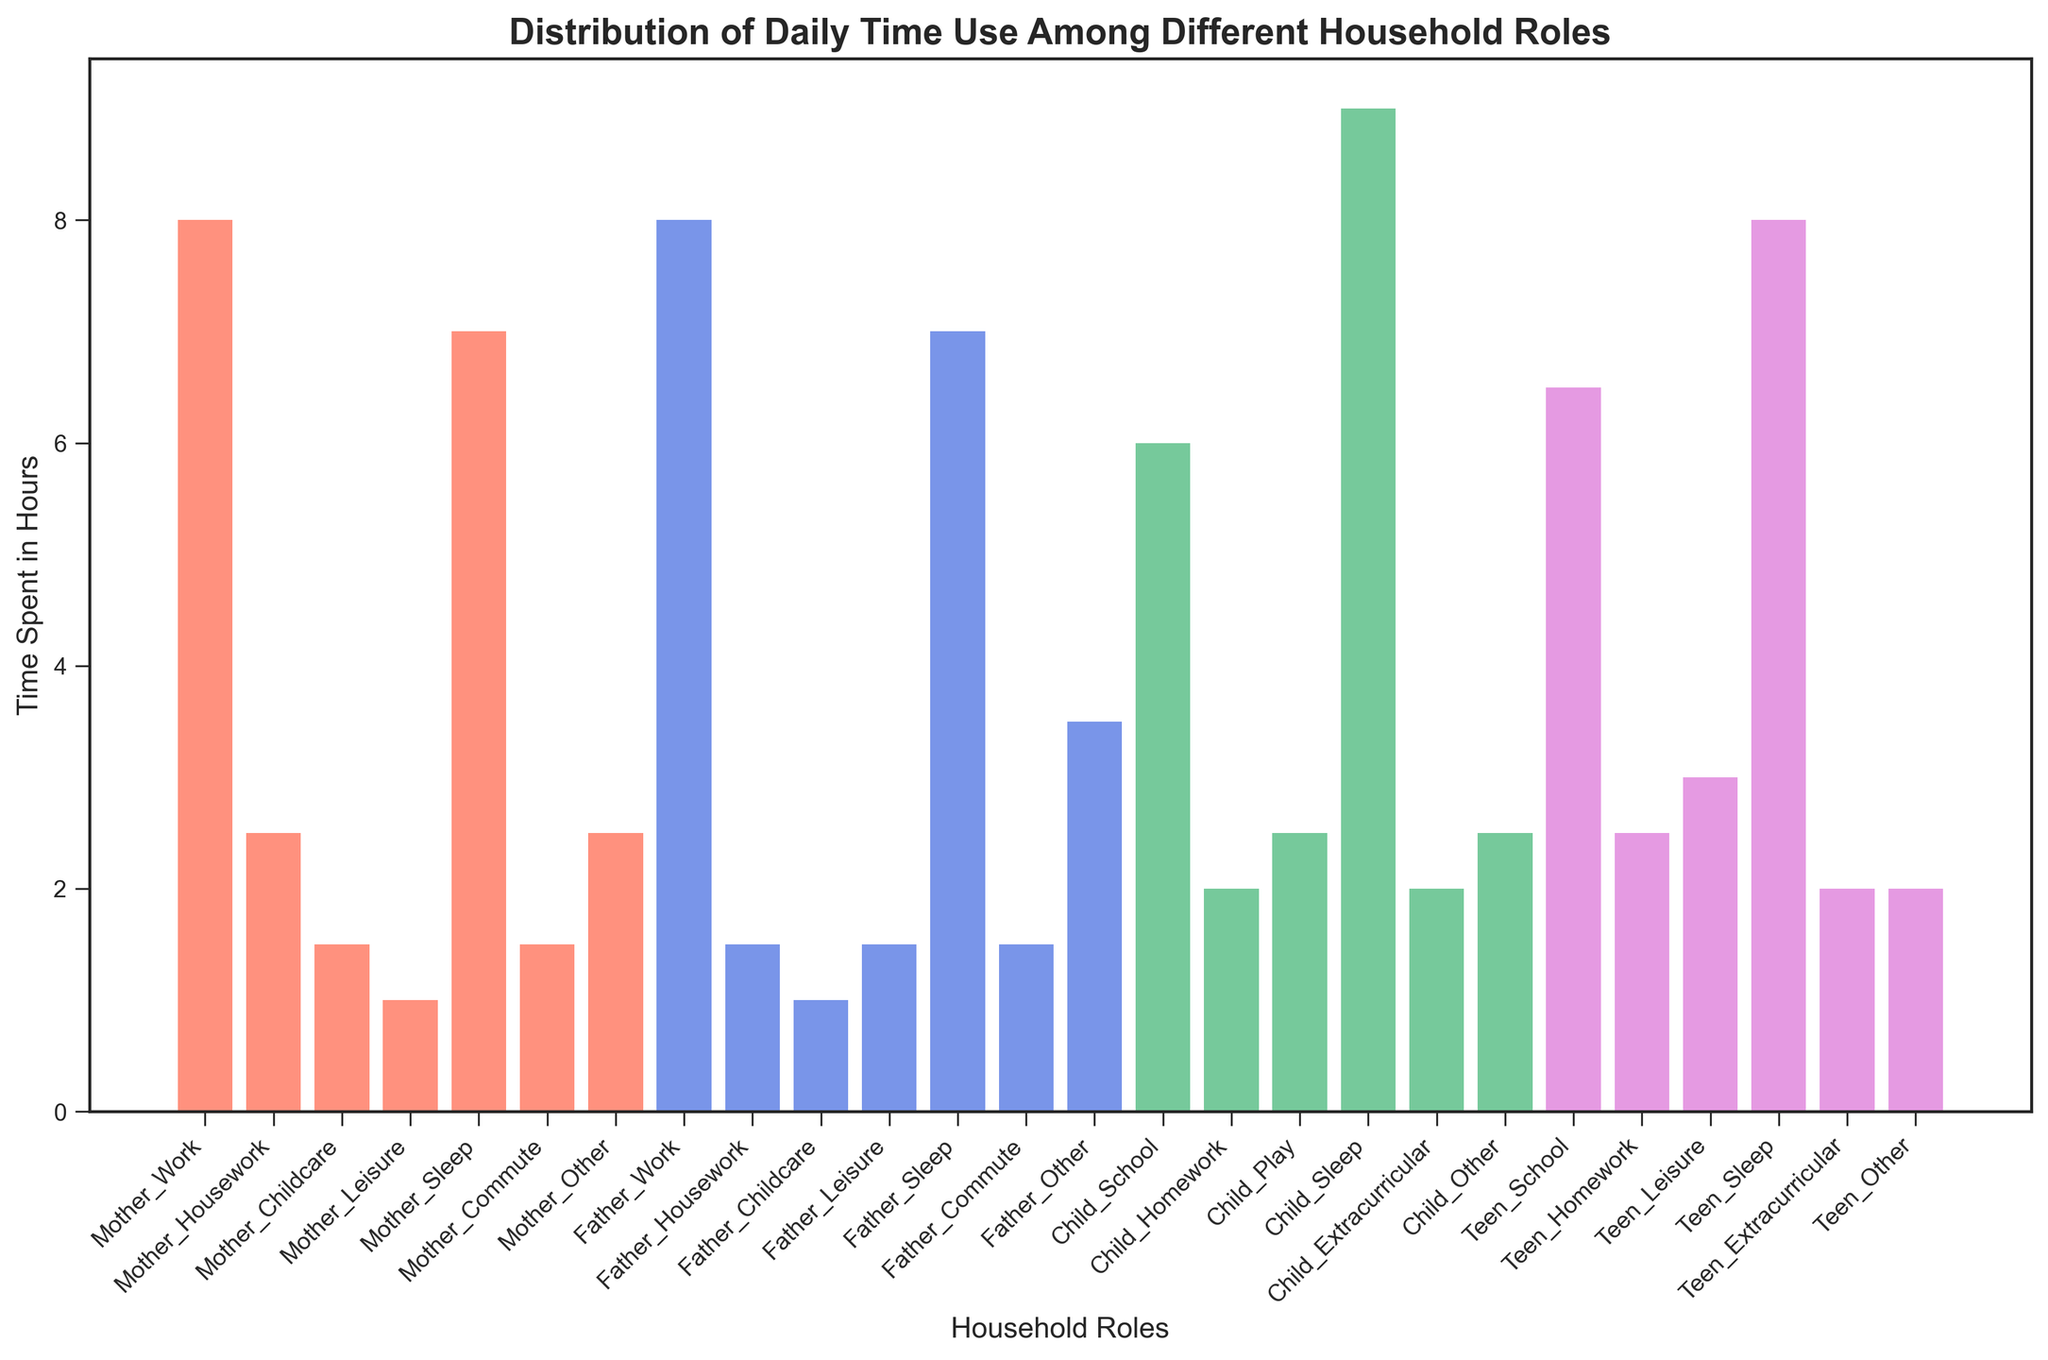What is the total time spent by mothers on work, housework, and childcare combined? To find the total time, sum the hours spent on work (8.0), housework (2.5), and childcare (1.5). 8.0 + 2.5 + 1.5 = 12.0 hours.
Answer: 12.0 hours Which role spends the most time sleeping? Compare the height of the bars representing sleep for each role: Mother (7.0), Father (7.0), Child (9.0), Teen (8.0). The Child has the tallest bar for sleep.
Answer: Child How does the time mothers spend on leisure compare to the time fathers spend on leisure? Compare the height of the bars for leisure: Mother's leisure (1.0) and Father's leisure (1.5). 1.5 is greater than 1.0, so fathers spend more time on leisure than mothers.
Answer: Fathers spend more time on leisure What is the average time spent by children on homework and extracurricular activities combined? Find the average of homework and extracurricular activities: Homework (2.0) and Extracurricular (2.0). (2.0 + 2.0) / 2 = 2.0 hours.
Answer: 2.0 hours Who spends more time on commuting, mothers or fathers? Compare the height of the bars representing commute: Mother (1.5) and Father (1.5). Both bars have the same height, so mothers and fathers spend the same time on commuting.
Answer: Same What is the difference in time spent on work between mothers and fathers? Compare the time spent on work by both: Mother's work (8.0) and Father's work (8.0). Both are equal, so the difference is 0 hours.
Answer: 0 hours Which role has the most diverse distribution of activities, excluding sleep? Observe the range of time spent on different activities for each role: Mother (work, housework, childcare, leisure, commute, other), Father (work, housework, childcare, leisure, commute, other), Child (school, homework, play, extracurricular, other), Teen (school, homework, leisure, extracurricular, other). Both adults (Mother and Father) have a more diverse distribution of activities compared to children and teens.
Answer: Adults Comparing sleep time, who has a greater difference between sleep and other activities: Children or Teens? Calculate the difference between sleep and other activities for both: Child’s Sleep (9.0) vs Other (2.5), difference = 9.0 - 2.5 = 6.5. Teen’s Sleep (8.0) vs Other (2.0), difference = 8.0 - 2.0 = 6.0. Children have a greater difference.
Answer: Children What is the combined total time spent on leisure by all roles? Sum the time spent on leisure by each role: Mother (1.0), Father (1.5), Teen (3.0), Child (0.0). 1.0 + 1.5 + 3.0 + 0.0 = 5.5 hours.
Answer: 5.5 hours 